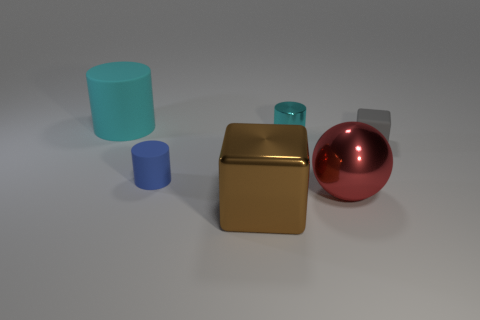There is a shiny object that is on the left side of the tiny cyan metal cylinder; does it have the same shape as the tiny matte object that is to the right of the big shiny cube?
Make the answer very short. Yes. How many matte objects are left of the cyan thing to the right of the blue cylinder in front of the cyan rubber cylinder?
Offer a terse response. 2. The ball has what color?
Give a very brief answer. Red. What number of other things are there of the same size as the brown metallic cube?
Ensure brevity in your answer.  2. What is the material of the other big thing that is the same shape as the blue rubber object?
Offer a terse response. Rubber. The cube left of the metal object that is behind the small thing that is to the right of the red thing is made of what material?
Give a very brief answer. Metal. There is a sphere that is made of the same material as the big block; what is its size?
Provide a succinct answer. Large. Are there any other things that are the same color as the small metal object?
Keep it short and to the point. Yes. Does the small cylinder to the right of the big brown metal thing have the same color as the rubber thing behind the tiny gray rubber object?
Give a very brief answer. Yes. There is a metallic object that is behind the large ball; what color is it?
Offer a very short reply. Cyan. 